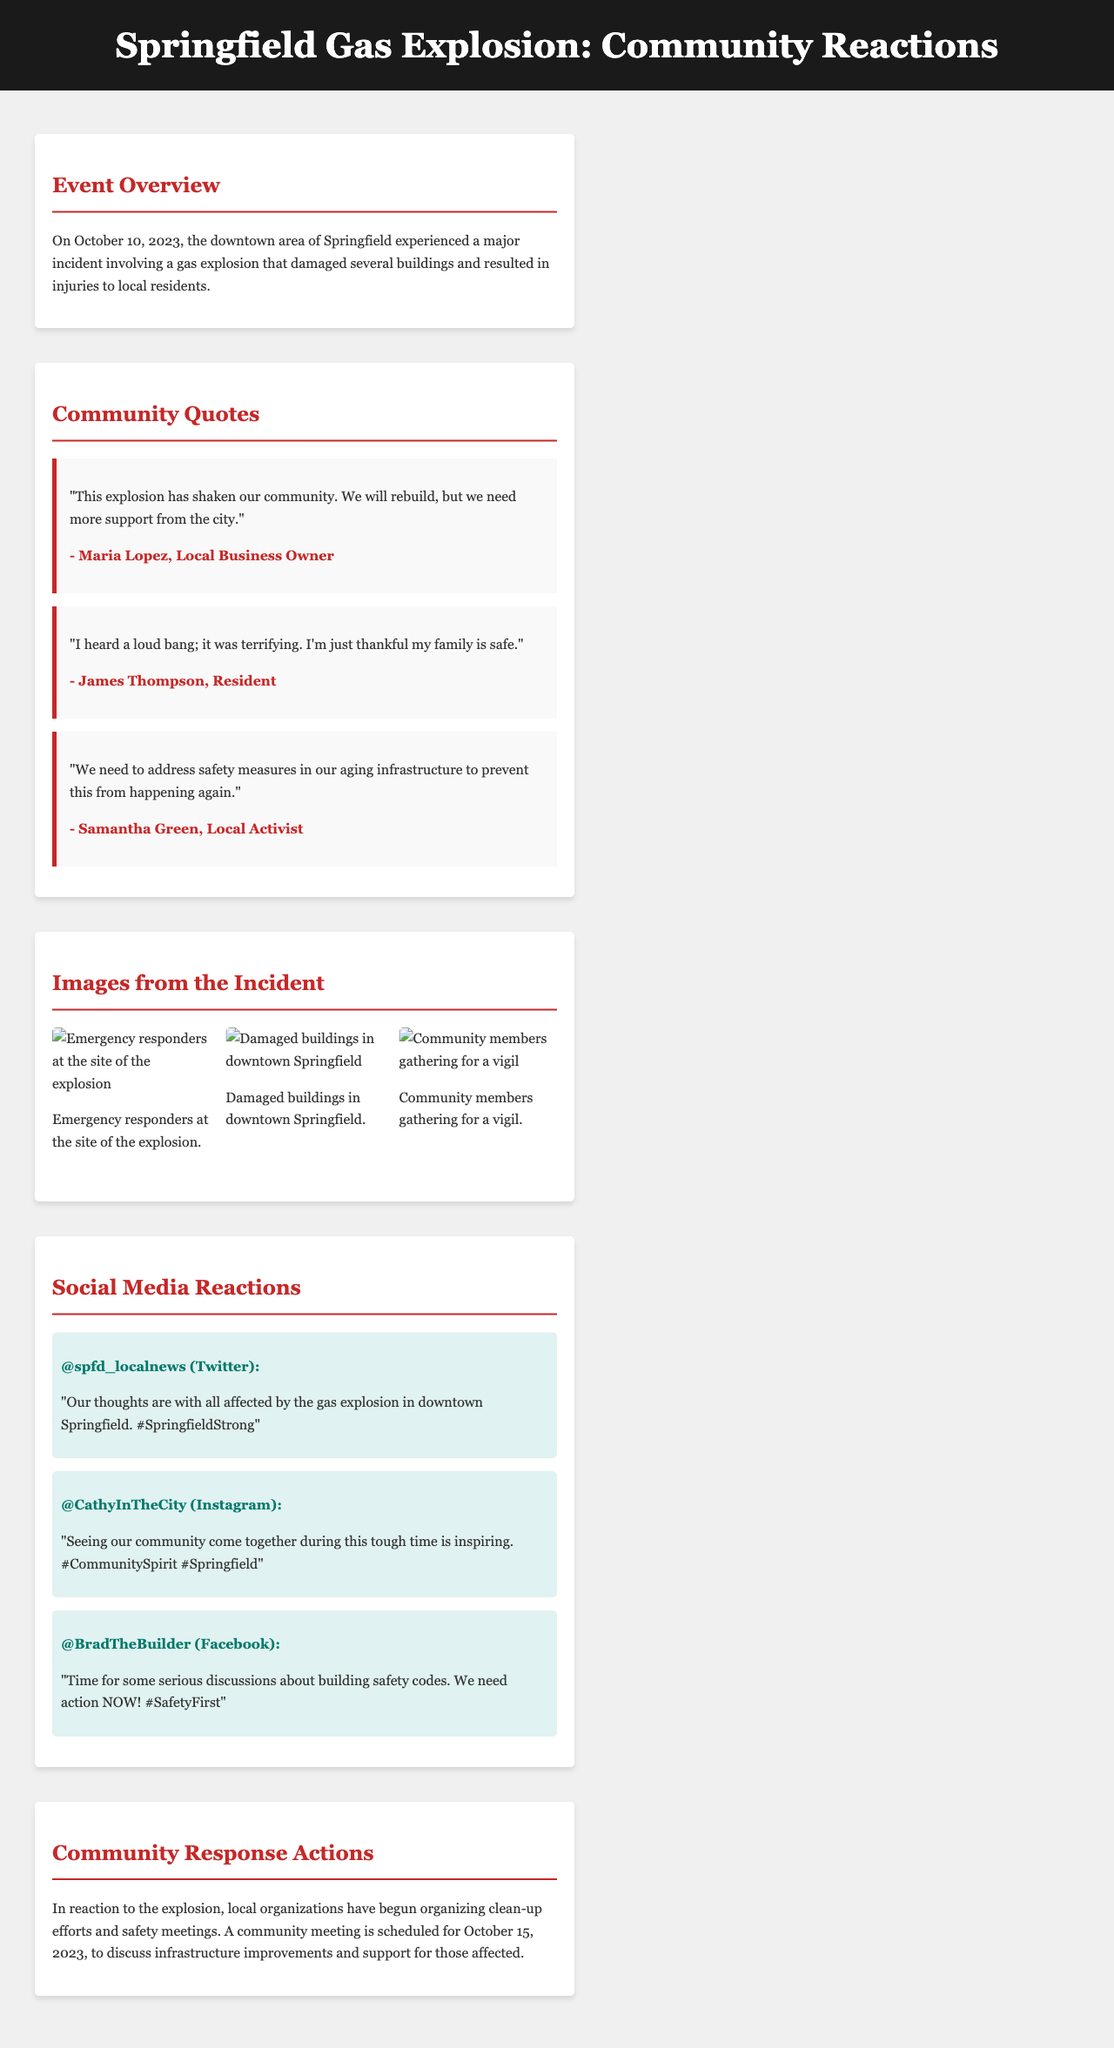What date did the gas explosion occur? The document states that the explosion occurred on October 10, 2023.
Answer: October 10, 2023 Who is a local business owner quoted in the report? The report features a quote from Maria Lopez, a local business owner.
Answer: Maria Lopez What was the community's immediate emotional reaction to the explosion? James Thompson mentions that the explosion was terrifying, indicating a fearful emotional reaction.
Answer: Terrifying How many images are included in the images section? The document lists three specific images related to the incident.
Answer: Three What topic will be discussed at the community meeting scheduled for October 15, 2023? The upcoming community meeting will discuss infrastructure improvements and support for affected individuals.
Answer: Infrastructure improvements Which social media platform did @CathyInTheCity post on? The username @CathyInTheCity is associated with Instagram, as mentioned in the document.
Answer: Instagram What has the community begun organizing in response to the explosion? The document states that local organizations are organizing clean-up efforts and safety meetings in response to the explosion.
Answer: Clean-up efforts What is the primary theme reflected in social media reactions? The social media responses predominantly reflect themes of community support and calls for safety improvements.
Answer: Community support 